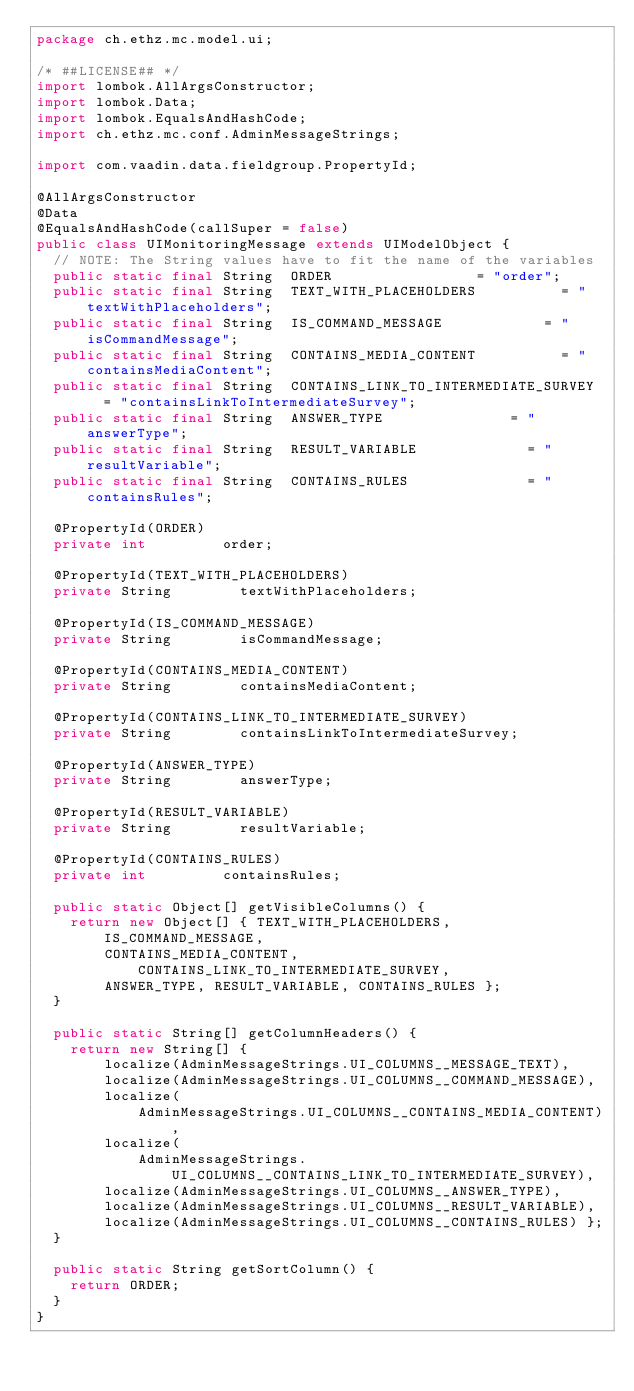<code> <loc_0><loc_0><loc_500><loc_500><_Java_>package ch.ethz.mc.model.ui;

/* ##LICENSE## */
import lombok.AllArgsConstructor;
import lombok.Data;
import lombok.EqualsAndHashCode;
import ch.ethz.mc.conf.AdminMessageStrings;

import com.vaadin.data.fieldgroup.PropertyId;

@AllArgsConstructor
@Data
@EqualsAndHashCode(callSuper = false)
public class UIMonitoringMessage extends UIModelObject {
	// NOTE: The String values have to fit the name of the variables
	public static final String	ORDER									= "order";
	public static final String	TEXT_WITH_PLACEHOLDERS					= "textWithPlaceholders";
	public static final String	IS_COMMAND_MESSAGE						= "isCommandMessage";
	public static final String	CONTAINS_MEDIA_CONTENT					= "containsMediaContent";
	public static final String	CONTAINS_LINK_TO_INTERMEDIATE_SURVEY	= "containsLinkToIntermediateSurvey";
	public static final String	ANSWER_TYPE								= "answerType";
	public static final String	RESULT_VARIABLE							= "resultVariable";
	public static final String	CONTAINS_RULES							= "containsRules";

	@PropertyId(ORDER)
	private int					order;

	@PropertyId(TEXT_WITH_PLACEHOLDERS)
	private String				textWithPlaceholders;

	@PropertyId(IS_COMMAND_MESSAGE)
	private String				isCommandMessage;

	@PropertyId(CONTAINS_MEDIA_CONTENT)
	private String				containsMediaContent;

	@PropertyId(CONTAINS_LINK_TO_INTERMEDIATE_SURVEY)
	private String				containsLinkToIntermediateSurvey;

	@PropertyId(ANSWER_TYPE)
	private String				answerType;

	@PropertyId(RESULT_VARIABLE)
	private String				resultVariable;

	@PropertyId(CONTAINS_RULES)
	private int					containsRules;

	public static Object[] getVisibleColumns() {
		return new Object[] { TEXT_WITH_PLACEHOLDERS, IS_COMMAND_MESSAGE,
				CONTAINS_MEDIA_CONTENT, CONTAINS_LINK_TO_INTERMEDIATE_SURVEY,
				ANSWER_TYPE, RESULT_VARIABLE, CONTAINS_RULES };
	}

	public static String[] getColumnHeaders() {
		return new String[] {
				localize(AdminMessageStrings.UI_COLUMNS__MESSAGE_TEXT),
				localize(AdminMessageStrings.UI_COLUMNS__COMMAND_MESSAGE),
				localize(
						AdminMessageStrings.UI_COLUMNS__CONTAINS_MEDIA_CONTENT),
				localize(
						AdminMessageStrings.UI_COLUMNS__CONTAINS_LINK_TO_INTERMEDIATE_SURVEY),
				localize(AdminMessageStrings.UI_COLUMNS__ANSWER_TYPE),
				localize(AdminMessageStrings.UI_COLUMNS__RESULT_VARIABLE),
				localize(AdminMessageStrings.UI_COLUMNS__CONTAINS_RULES) };
	}

	public static String getSortColumn() {
		return ORDER;
	}
}
</code> 